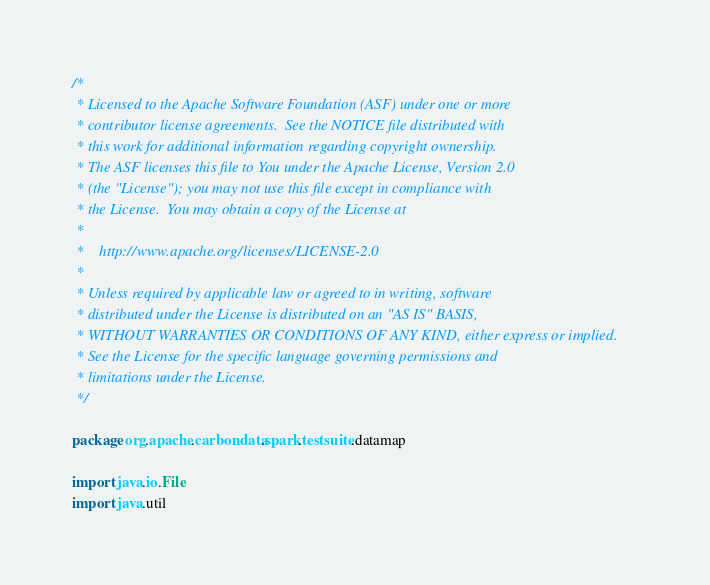Convert code to text. <code><loc_0><loc_0><loc_500><loc_500><_Scala_>/*
 * Licensed to the Apache Software Foundation (ASF) under one or more
 * contributor license agreements.  See the NOTICE file distributed with
 * this work for additional information regarding copyright ownership.
 * The ASF licenses this file to You under the Apache License, Version 2.0
 * (the "License"); you may not use this file except in compliance with
 * the License.  You may obtain a copy of the License at
 *
 *    http://www.apache.org/licenses/LICENSE-2.0
 *
 * Unless required by applicable law or agreed to in writing, software
 * distributed under the License is distributed on an "AS IS" BASIS,
 * WITHOUT WARRANTIES OR CONDITIONS OF ANY KIND, either express or implied.
 * See the License for the specific language governing permissions and
 * limitations under the License.
 */

package org.apache.carbondata.spark.testsuite.datamap

import java.io.File
import java.util
</code> 